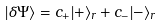Convert formula to latex. <formula><loc_0><loc_0><loc_500><loc_500>| \delta \Psi \rangle = c _ { + } | + \rangle _ { r } + c _ { - } | - \rangle _ { r }</formula> 